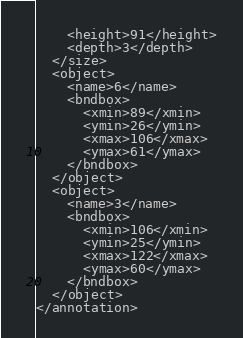Convert code to text. <code><loc_0><loc_0><loc_500><loc_500><_XML_>    <height>91</height>
    <depth>3</depth>
  </size>
  <object>
    <name>6</name>
    <bndbox>
      <xmin>89</xmin>
      <ymin>26</ymin>
      <xmax>106</xmax>
      <ymax>61</ymax>
    </bndbox>
  </object>
  <object>
    <name>3</name>
    <bndbox>
      <xmin>106</xmin>
      <ymin>25</ymin>
      <xmax>122</xmax>
      <ymax>60</ymax>
    </bndbox>
  </object>
</annotation>
</code> 